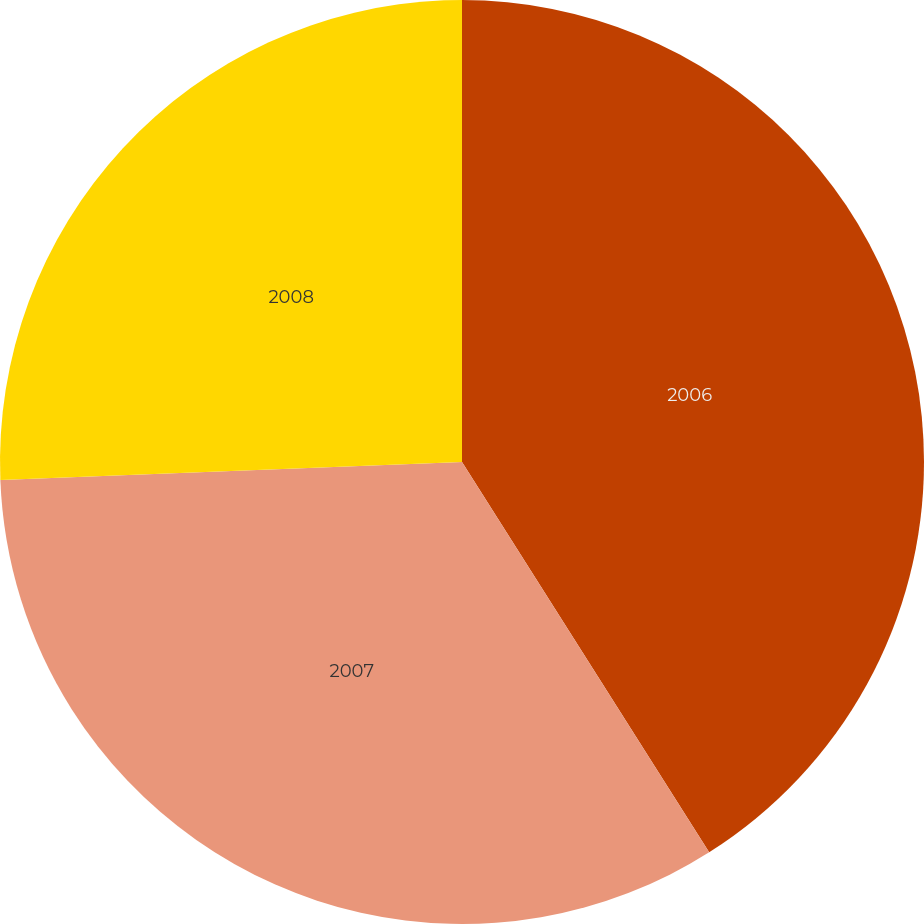Convert chart to OTSL. <chart><loc_0><loc_0><loc_500><loc_500><pie_chart><fcel>2006<fcel>2007<fcel>2008<nl><fcel>41.02%<fcel>33.37%<fcel>25.62%<nl></chart> 